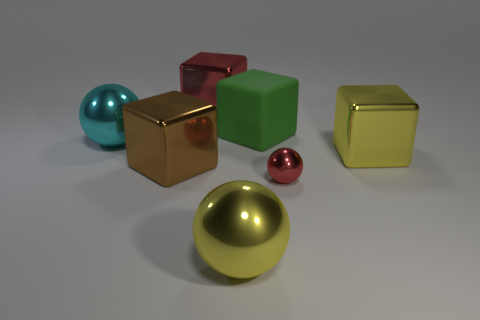Subtract all large yellow balls. How many balls are left? 2 Add 1 balls. How many objects exist? 8 Subtract 3 cubes. How many cubes are left? 1 Subtract all red blocks. How many blocks are left? 3 Subtract all cubes. How many objects are left? 3 Subtract all red spheres. Subtract all gray cubes. How many spheres are left? 2 Subtract all large red metallic cubes. Subtract all yellow objects. How many objects are left? 4 Add 6 large cyan metallic balls. How many large cyan metallic balls are left? 7 Add 1 brown metal things. How many brown metal things exist? 2 Subtract 0 blue blocks. How many objects are left? 7 